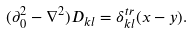Convert formula to latex. <formula><loc_0><loc_0><loc_500><loc_500>( \partial _ { 0 } ^ { 2 } - \nabla ^ { 2 } ) D _ { k l } = \delta _ { k l } ^ { t r } ( x - y ) .</formula> 